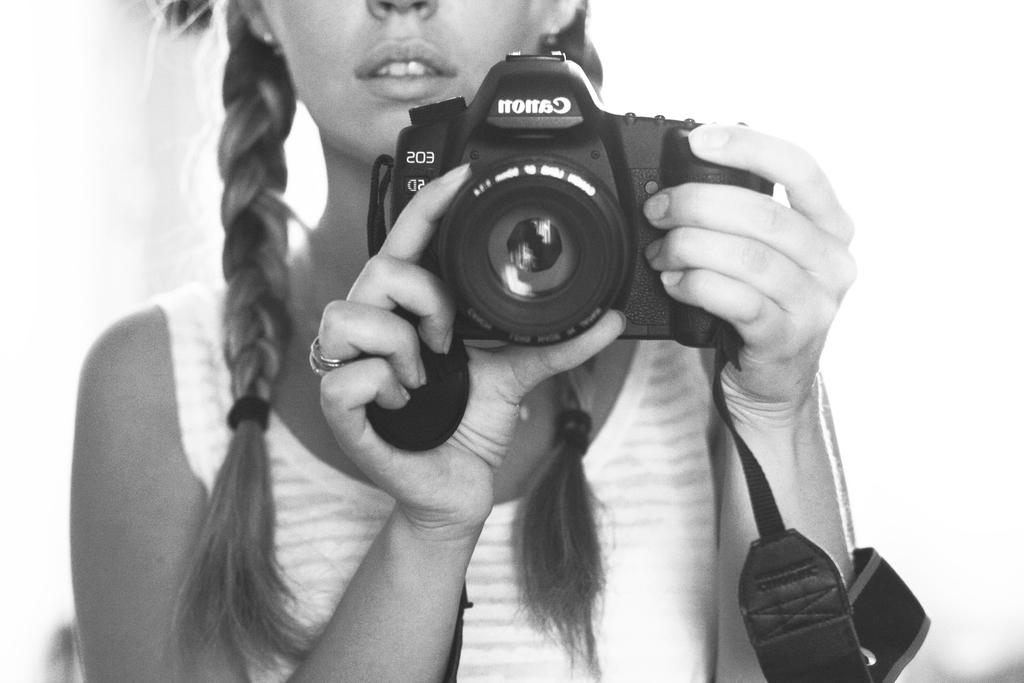What is the main subject of the image? The main subject of the image is a woman. What is the woman holding in the image? The woman is holding a camera with her hands. What is the woman wearing in the image? The woman is wearing a white T-shirt. Can you taste the cherries in the image? There are no cherries present in the image, so it is not possible to taste them. 